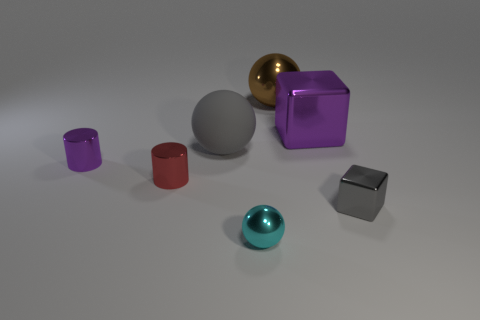What is the brown ball made of?
Your answer should be very brief. Metal. Are any gray shiny objects visible?
Offer a very short reply. Yes. The big ball that is in front of the big brown object is what color?
Your answer should be compact. Gray. There is a sphere that is behind the purple metal object that is on the right side of the red cylinder; how many tiny purple metal cylinders are behind it?
Offer a terse response. 0. The sphere that is in front of the large purple metal block and behind the tiny gray cube is made of what material?
Ensure brevity in your answer.  Rubber. Is the cyan sphere made of the same material as the big ball in front of the large metallic cube?
Your answer should be compact. No. Are there more shiny cylinders that are behind the small red metallic cylinder than big purple objects that are left of the big rubber object?
Your response must be concise. Yes. The big gray rubber thing is what shape?
Make the answer very short. Sphere. Is the material of the purple block that is right of the big matte ball the same as the gray object that is in front of the big rubber ball?
Provide a short and direct response. Yes. The gray thing behind the tiny red metal cylinder has what shape?
Your answer should be very brief. Sphere. 